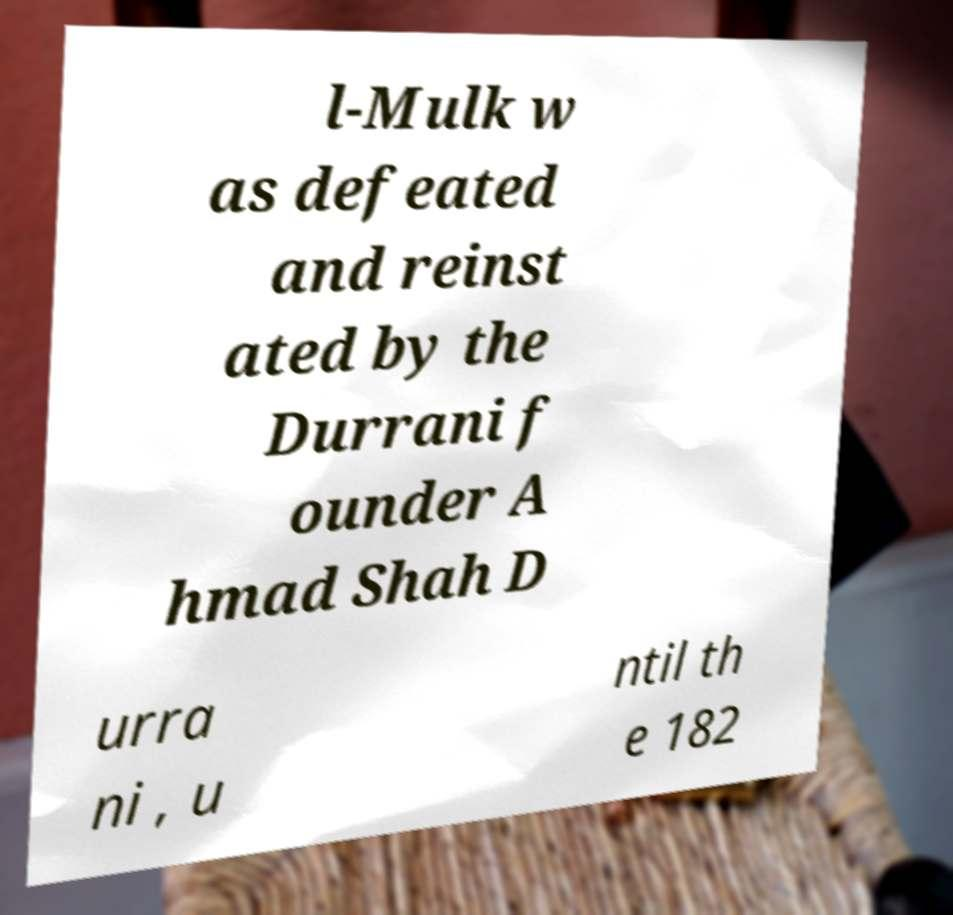Could you assist in decoding the text presented in this image and type it out clearly? l-Mulk w as defeated and reinst ated by the Durrani f ounder A hmad Shah D urra ni , u ntil th e 182 